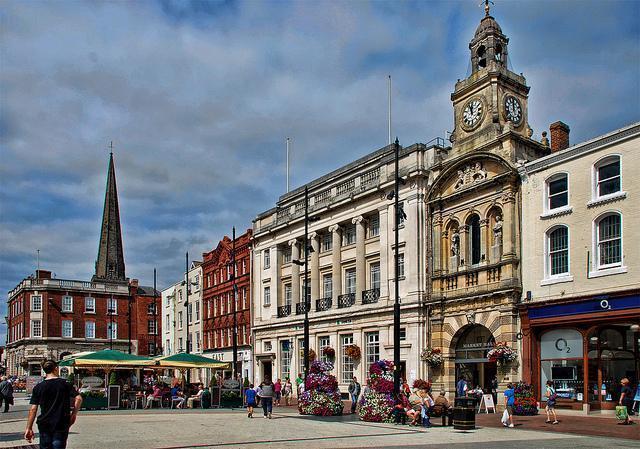How many clock faces can be seen on the clock tower?
Pick the correct solution from the four options below to address the question.
Options: Two, four, one, three. Two. 